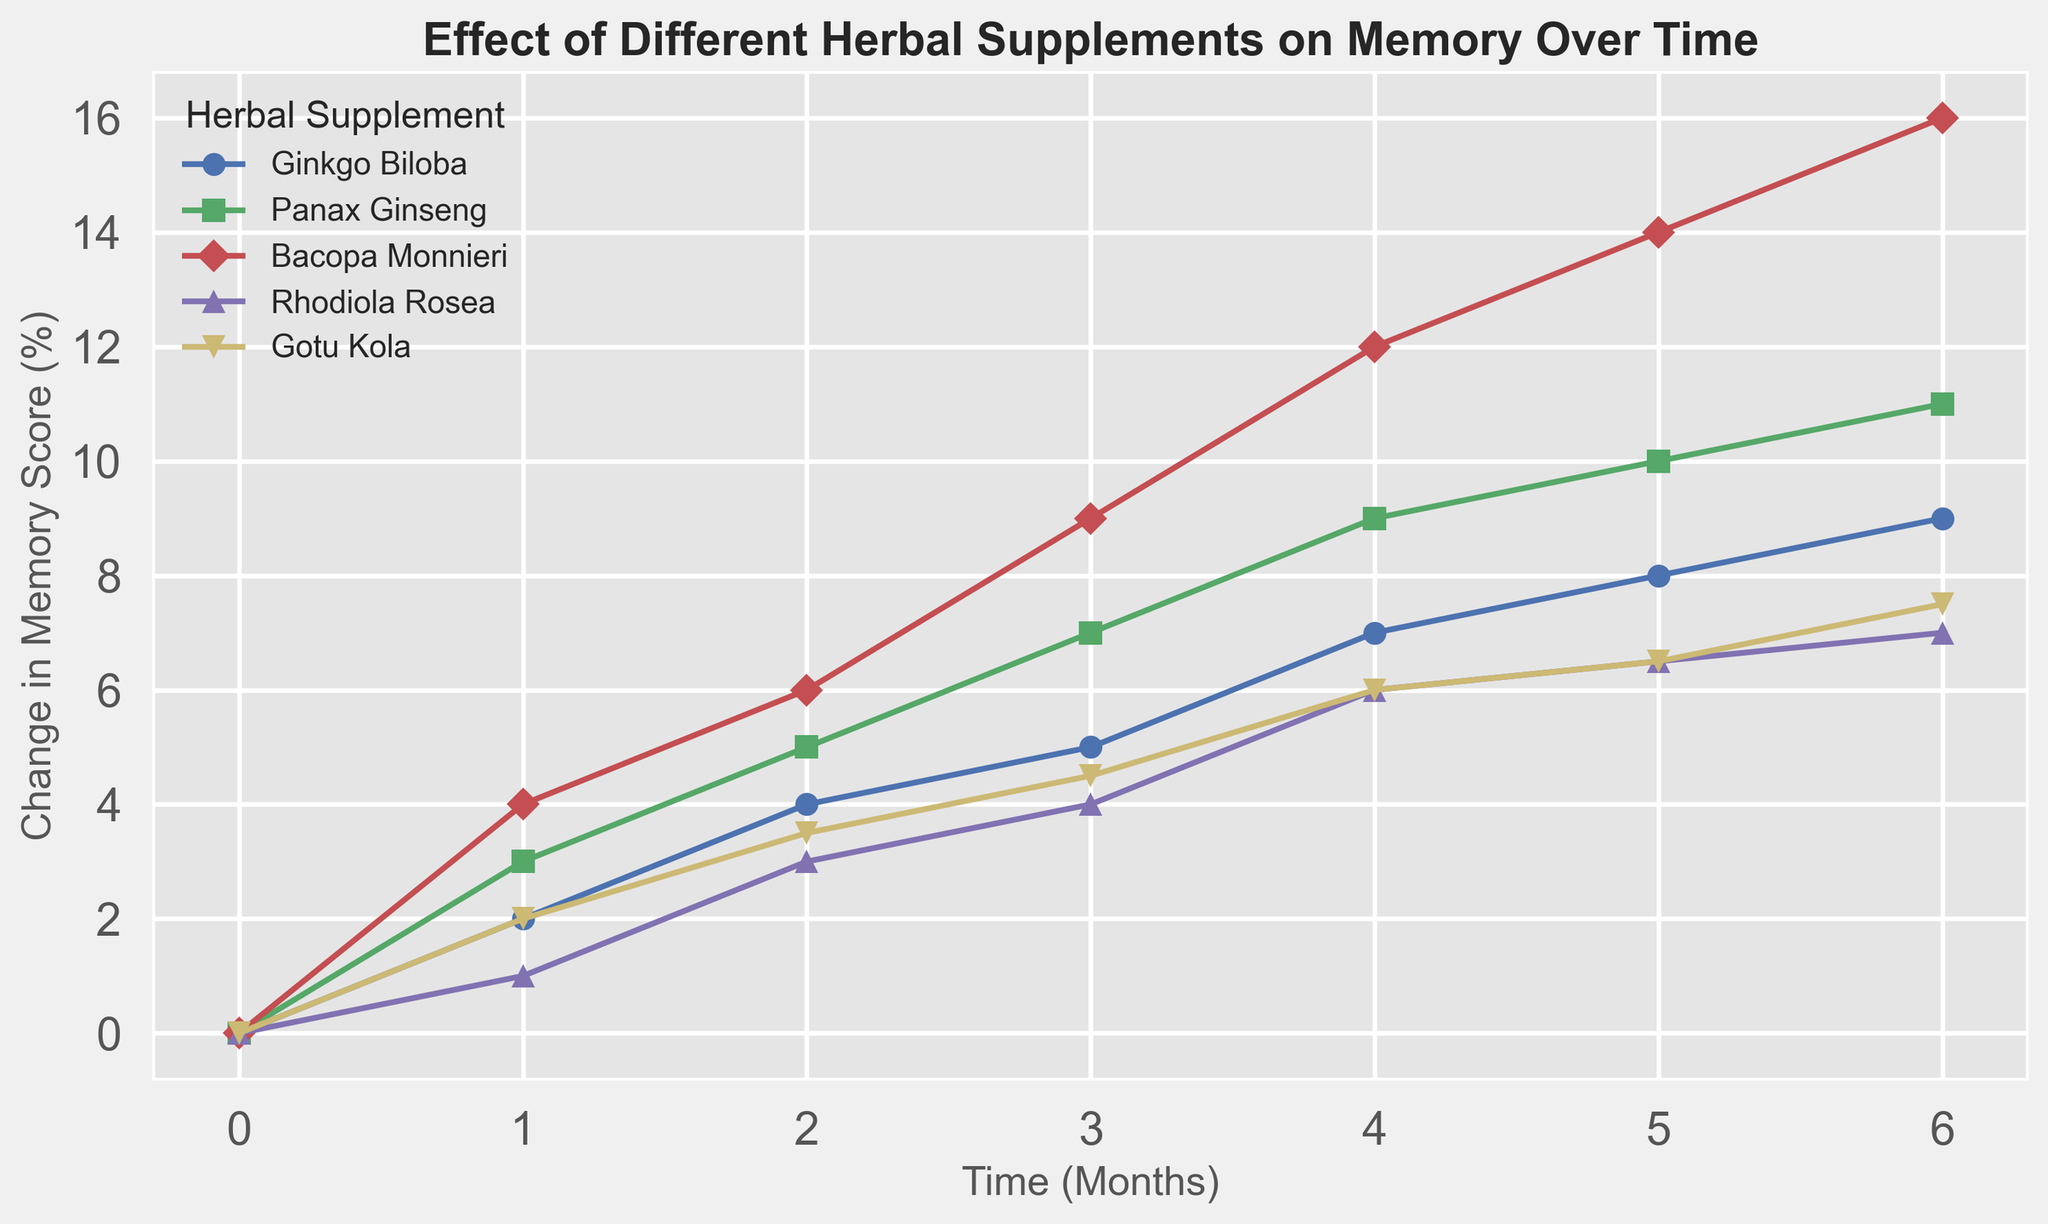What is the change in memory score for Panax Ginseng at month 4? The line for Panax Ginseng shows a data point at month 4 with a change in memory score of 9%.
Answer: 9% Which supplement shows the highest increase in memory score over 6 months? By examining the endpoints of the lines, Bacopa Monnieri reaches the highest change in memory score with 16% after 6 months.
Answer: Bacopa Monnieri How does the memory score for Ginkgo Biloba change from month 2 to month 4? At month 2, Ginkgo Biloba has a 4% increase in memory score, and at month 4, it has a 7% increase. The difference is 7% - 4% = 3%.
Answer: 3% Which supplement has the smallest increase in memory score at month 6? Rhodiola Rosea has the smallest increase at 7% after 6 months, as can be seen by comparing the endpoints of the lines.
Answer: Rhodiola Rosea Between month 1 and month 3, which supplement shows the greatest increase in memory score? Bacopa Monnieri increases from 4% to 9% between month 1 and month 3, a difference of 5%. This is the largest increase among the supplements.
Answer: Bacopa Monnieri What is the average change in memory score for Gotu Kola over 6 months? The memory score changes for Gotu Kola at months 1 through 6 are 2%, 3.5%, 4.5%, 6%, 6.5%, and 7.5%. The average is calculated as (2 + 3.5 + 4.5 + 6 + 6.5 + 7.5) / 6 = 30 / 6 = 5%.
Answer: 5% Which supplement shows a faster initial improvement in memory, Ginkgo Biloba or Panax Ginseng? After 1 month, Ginkgo Biloba shows a 2% increase, while Panax Ginseng shows a 3% increase, indicating that Panax Ginseng shows a faster initial improvement.
Answer: Panax Ginseng How much more did Bacopa Monnieri improve memory score than Rhodiola Rosea at month 5? At month 5, Bacopa Monnieri has a 14% increase, while Rhodiola Rosea has a 6.5% increase. The difference is 14% - 6.5% = 7.5%.
Answer: 7.5% What is the general trend observed for all supplements over time? All supplements show an increasing trend in memory score over time, indicating a positive effect on memory improvement across the months.
Answer: Increasing trend 